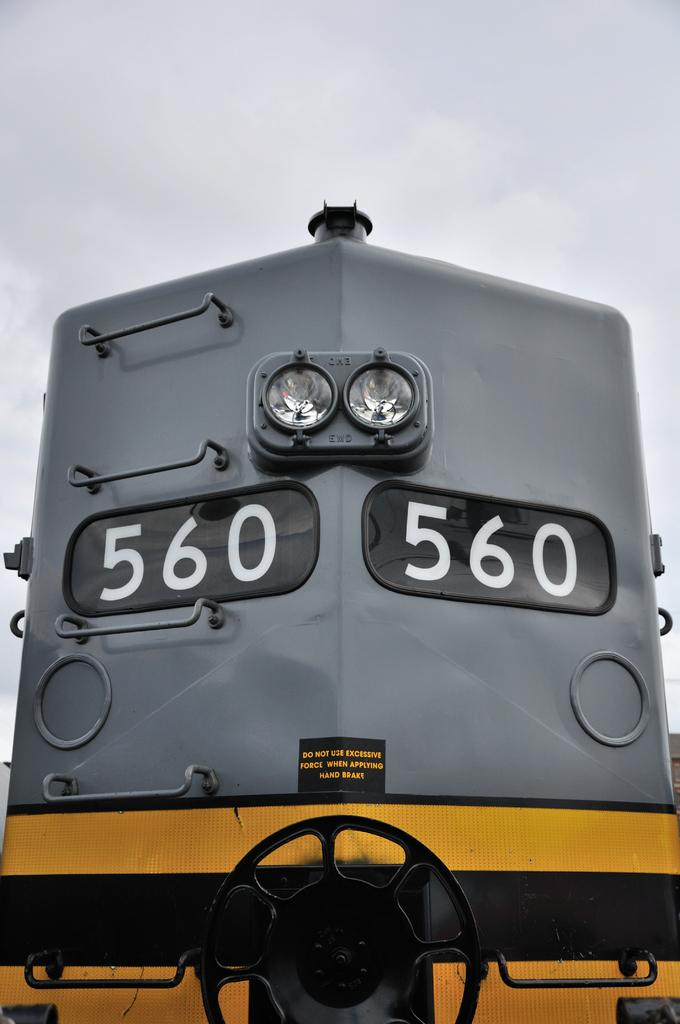What is the main subject of the image? The main subject of the image is a train. What can be seen in the background of the image? The sky is visible in the background of the image. What type of base is supporting the train in the image? There is no specific base supporting the train in the image; it is likely on train tracks. What type of truck can be seen transporting the train in the image? There is no truck present in the image; it features a train. 